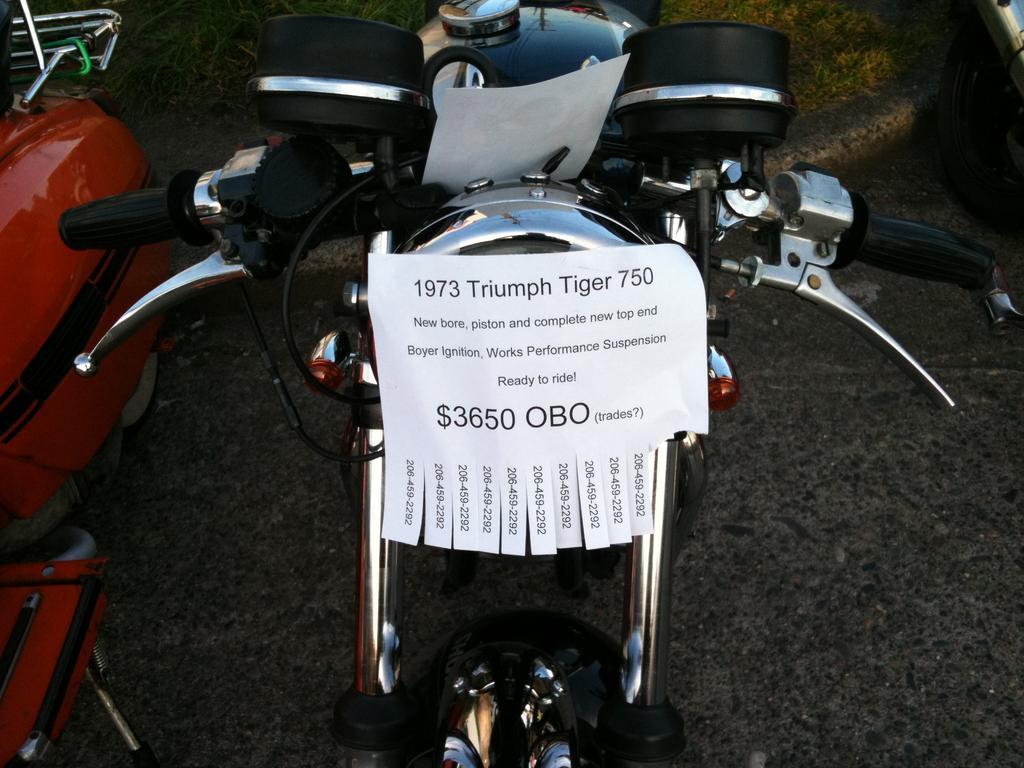Could you give a brief overview of what you see in this image? In the image there is a vehicle in the foreground and on the vehicle there is some paper, on the paper there are numbers and some text. 